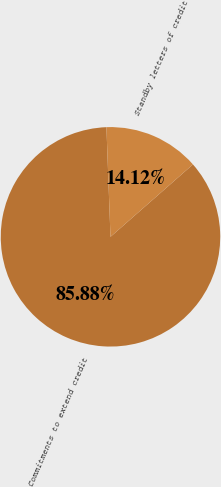Convert chart. <chart><loc_0><loc_0><loc_500><loc_500><pie_chart><fcel>Commitments to extend credit<fcel>Standby letters of credit<nl><fcel>85.88%<fcel>14.12%<nl></chart> 